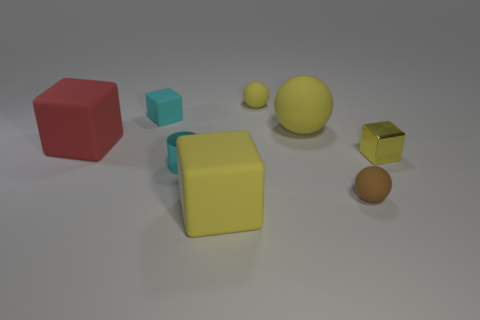Is the cylinder the same color as the tiny rubber cube?
Offer a very short reply. Yes. There is a rubber thing that is the same color as the tiny cylinder; what is its shape?
Ensure brevity in your answer.  Cube. What is the large yellow ball made of?
Ensure brevity in your answer.  Rubber. How big is the brown rubber ball that is behind the yellow matte cube?
Your answer should be compact. Small. What number of small yellow things are the same shape as the brown rubber thing?
Provide a short and direct response. 1. There is a tiny cyan thing that is made of the same material as the brown object; what is its shape?
Your response must be concise. Cube. What number of purple objects are either large rubber spheres or tiny metallic things?
Your response must be concise. 0. Are there any metal things to the right of the small brown sphere?
Give a very brief answer. Yes. Does the tiny rubber object that is in front of the metal cylinder have the same shape as the thing behind the tiny cyan cube?
Your response must be concise. Yes. What material is the other tiny object that is the same shape as the tiny brown rubber thing?
Keep it short and to the point. Rubber. 